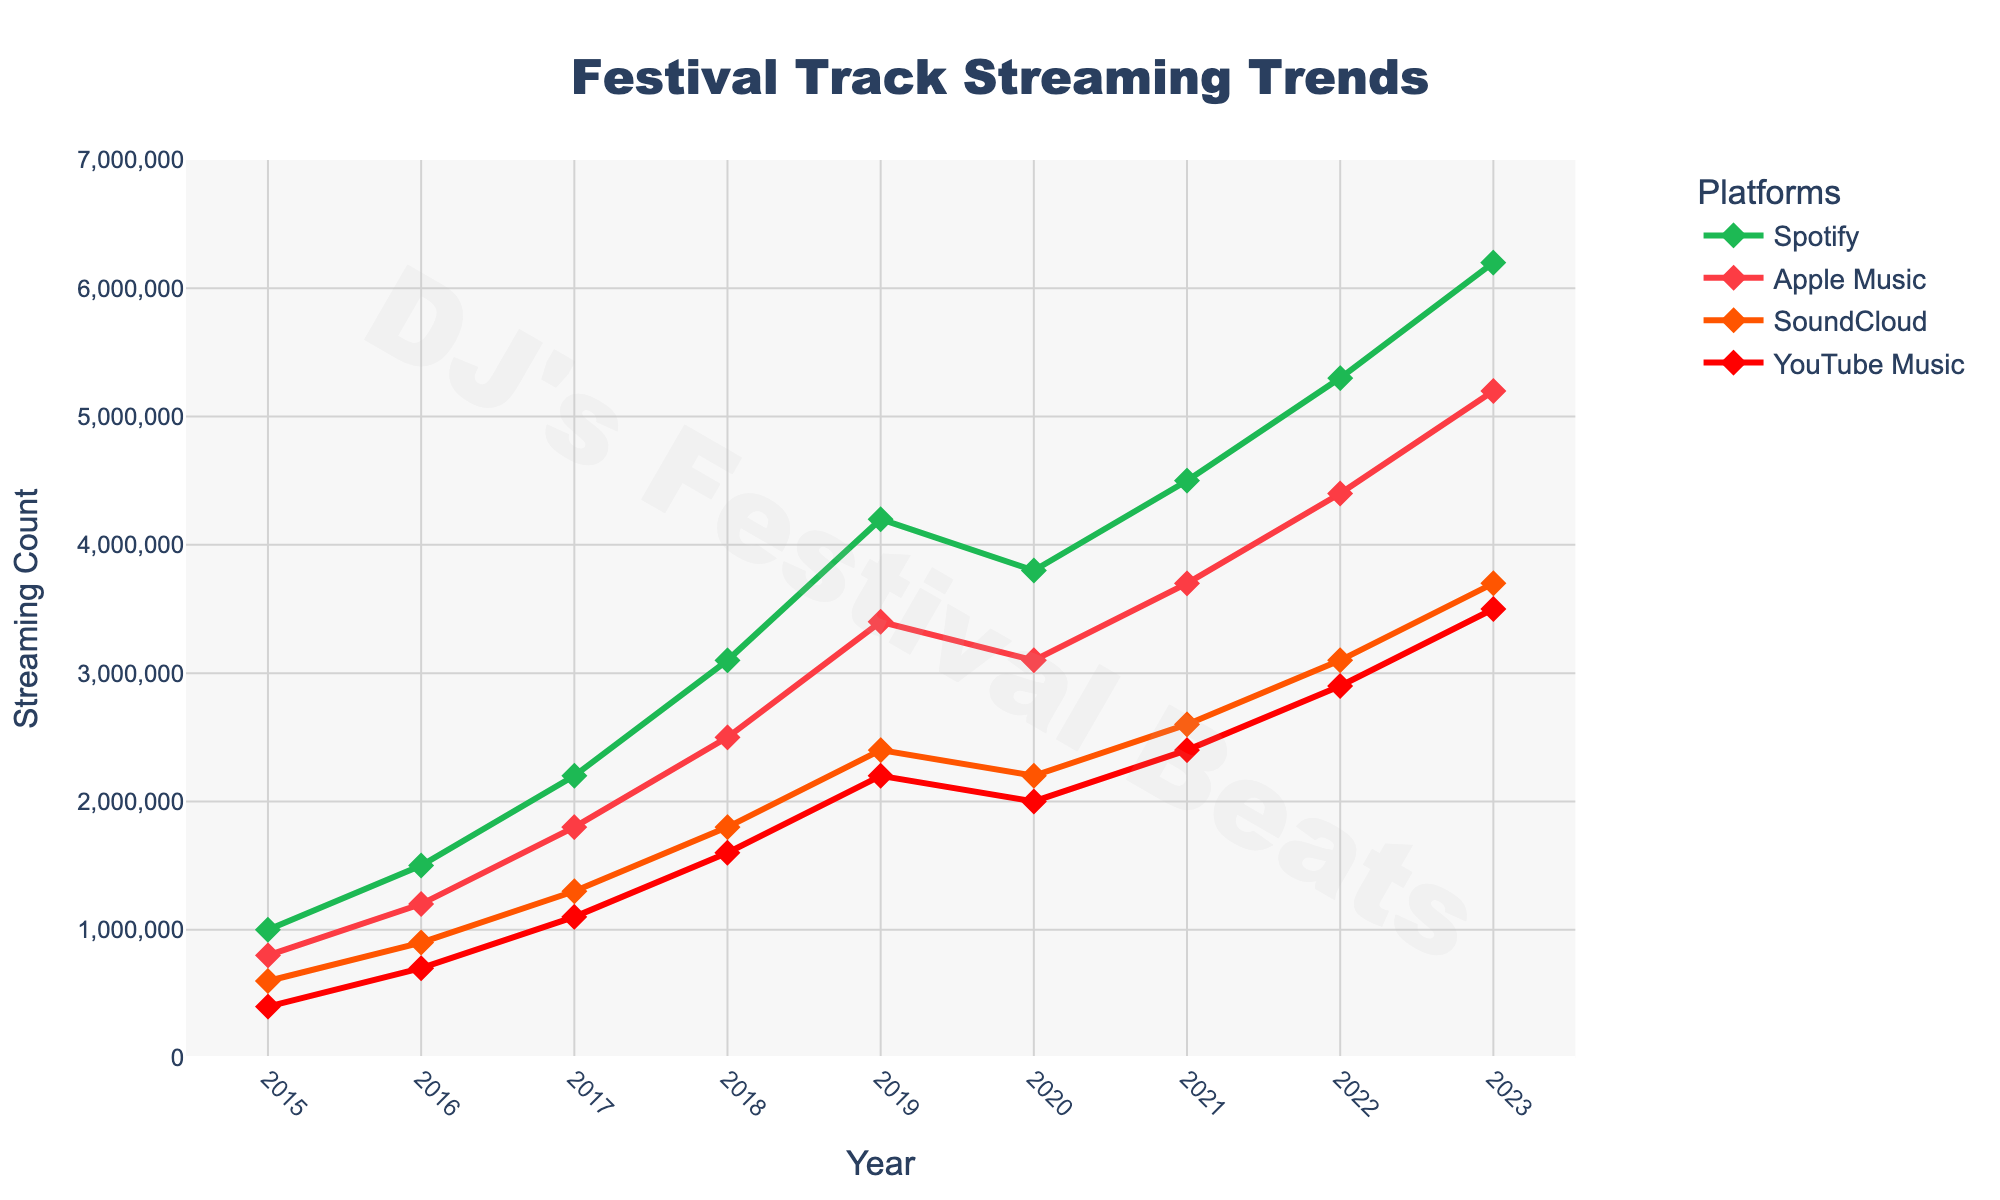How did the streaming numbers for Spotify change from 2015 to 2023? To find the change in Spotify streaming numbers from 2015 to 2023, subtract the 2015 value from the 2023 value: 6,200,000 - 1,000,000 = 5,200,000.
Answer: The streaming numbers for Spotify increased by 5,200,000 from 2015 to 2023 Which platform had the highest streaming numbers in 2023? Look for the highest data point in 2023 across the platforms. Spotify has 6,200,000, Apple Music has 5,200,000, SoundCloud has 3,700,000, and YouTube Music has 3,500,000. Spotify has the highest number.
Answer: Spotify Between which years did Apple Music see the most significant increase in streaming numbers? Calculate the difference in streaming numbers for each year and identify the highest increase. The most significant increase occurred from 2017 to 2018: 2,500,000 - 1,800,000 = 700,000.
Answer: 2017 to 2018 In what year did YouTube Music first surpass 2,000,000 streams? Identify the year when YouTube Music's streaming numbers first exceed 2,000,000 streams. This happened in 2019 with 2,200,000 streams.
Answer: 2019 By how much did the streaming numbers for SoundCloud increase from 2016 to 2023? Subtract the 2016 value from the 2023 value for SoundCloud: 3,700,000 - 900,000 = 2,800,000.
Answer: The streaming numbers for SoundCloud increased by 2,800,000 from 2016 to 2023 What is the average streaming number for Apple Music from 2015 to 2023? Add all the Apple Music numbers from 2015 to 2023 and divide by the number of years: (800,000 + 1,200,000 + 1,800,000 + 2,500,000 + 3,400,000 + 3,100,000 + 3,700,000 + 4,400,000 + 5,200,000) / 9 = 28,100,000 / 9 ≈ 3,122,222.
Answer: 3,122,222 Compare the average yearly growth rate of Spotify and YouTube Music between 2015 and 2023. Which was higher? Calculate the growth rate for each: Spotify's growth is (6,200,000 - 1,000,000)/8 = 650,000, and YouTube Music's growth is (3,500,000 - 400,000)/8 = 387,500.
Answer: Spotify's growth rate was higher Which platform had the smallest streaming count in 2020, and what was the count? Look at the 2020 data point for each platform. YouTube Music had the smallest count with 2,000,000 streams.
Answer: YouTube Music with 2,000,000 streams What was the total increase in streaming numbers for all platforms combined from 2015 to 2023? Calculate the total initial and final sums and then find the difference: (6,200,000 + 5,200,000 + 3,700,000 + 3,500,000) - (1,000,000 + 800,000 + 600,000 + 400,000) = 18,600,000 - 2,800,000 = 15,800,000.
Answer: 15,800,000 In which year did Spotify first surpass 3,000,000 streams? Identify the year when Spotify's streaming numbers first exceed 3,000,000. This happened in 2018 with 3,100,000 streams.
Answer: 2018 